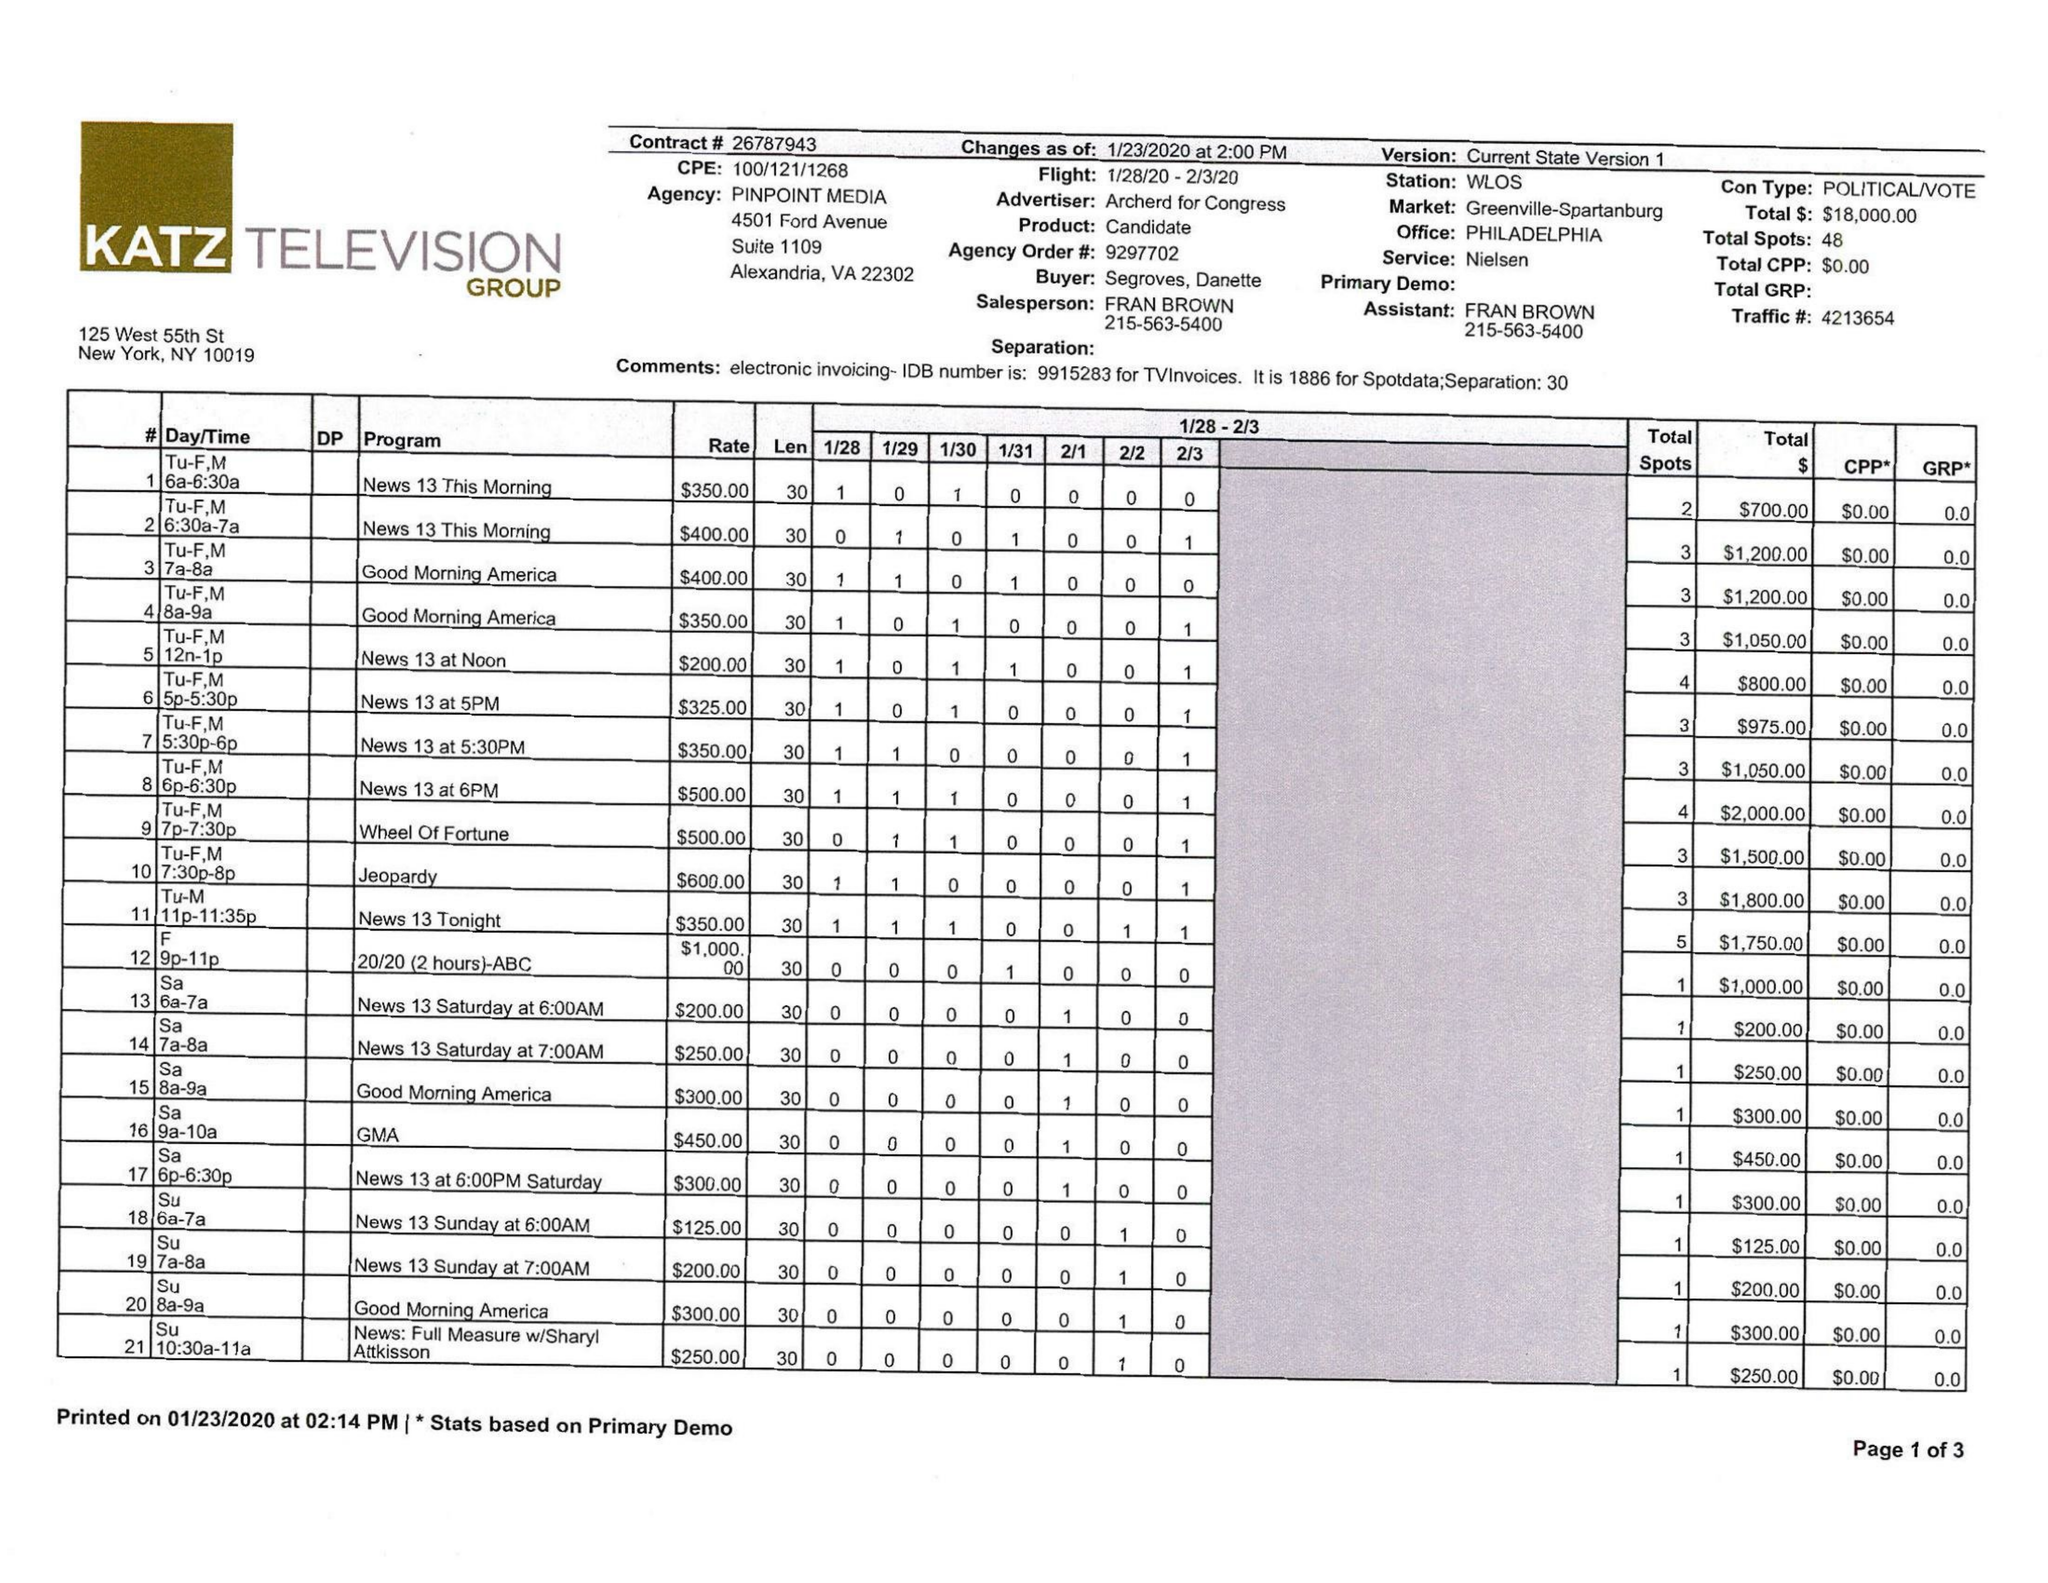What is the value for the contract_num?
Answer the question using a single word or phrase. 26787943 